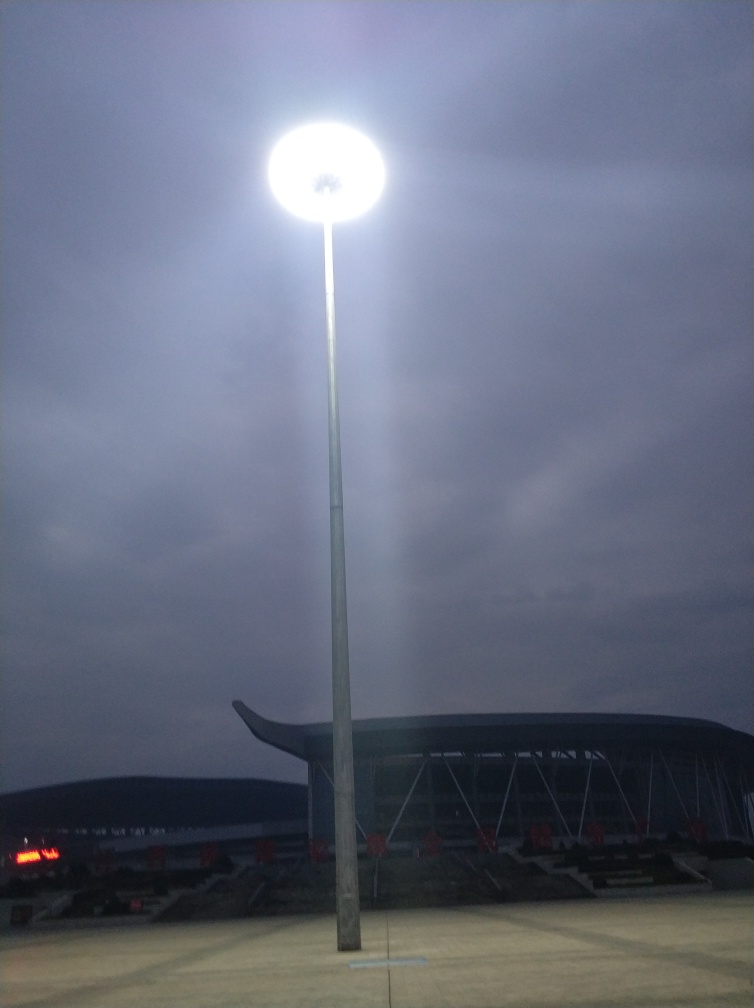Describe the weather conditions that can be inferred from the image. The sky appears overcast, with thick clouds suggesting that it might be a cool or humid evening. The absence of visible precipitation or shine on surfaces suggests it's not actively raining, but the cloud cover indicates it could potentially rain later. 